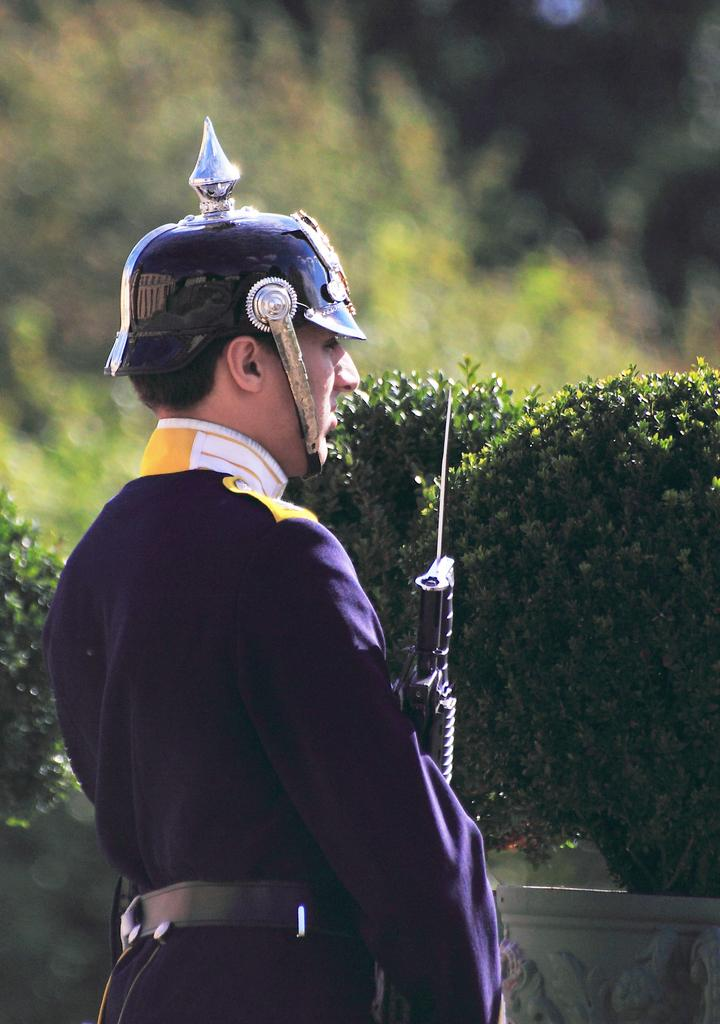What is the main subject of the image? There is a man standing in the image. What is the man wearing on his head? The man is wearing an object on his head. What is the man holding in the image? The man is holding an object. What type of vegetation can be seen in the image? There are plants and trees in the image. How many chickens are present in the image? There are no chickens visible in the image. What nation is represented by the man in the image? The image does not provide any information about the man's nationality or the nation he represents. 